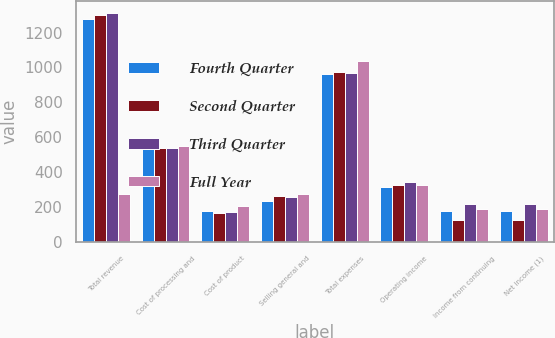Convert chart to OTSL. <chart><loc_0><loc_0><loc_500><loc_500><stacked_bar_chart><ecel><fcel>Total revenue<fcel>Cost of processing and<fcel>Cost of product<fcel>Selling general and<fcel>Total expenses<fcel>Operating income<fcel>Income from continuing<fcel>Net income (1)<nl><fcel>Fourth Quarter<fcel>1275<fcel>542<fcel>181<fcel>238<fcel>961<fcel>314<fcel>178<fcel>178<nl><fcel>Second Quarter<fcel>1298<fcel>542<fcel>168<fcel>262<fcel>972<fcel>326<fcel>127<fcel>127<nl><fcel>Third Quarter<fcel>1313<fcel>541<fcel>172<fcel>258<fcel>971<fcel>342<fcel>218<fcel>218<nl><fcel>Full Year<fcel>276<fcel>553<fcel>210<fcel>276<fcel>1039<fcel>329<fcel>189<fcel>189<nl></chart> 